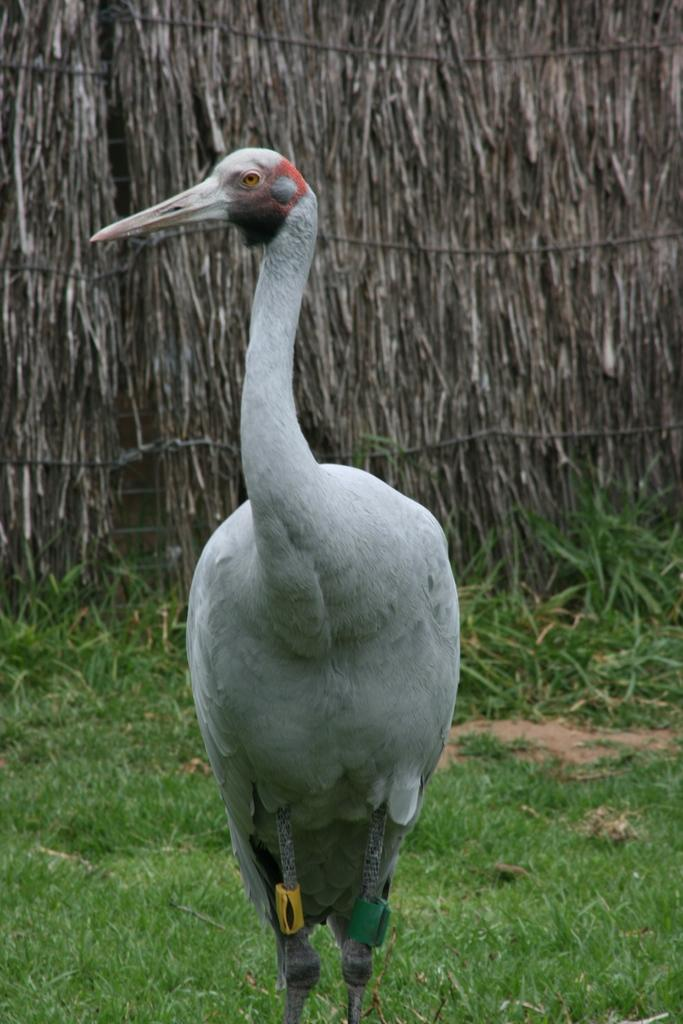What type of animal can be seen in the image? There is a bird in the image. Where is the bird located? The bird is standing on the ground. What is the ground covered with? There is grass on the ground. What can be seen in the background of the image? There is a wall in the background of the image. What material is the wall made of? The wall is made up of sticks. How does the bird look at the lock in the image? There is no lock present in the image, so the bird cannot look at a lock. 